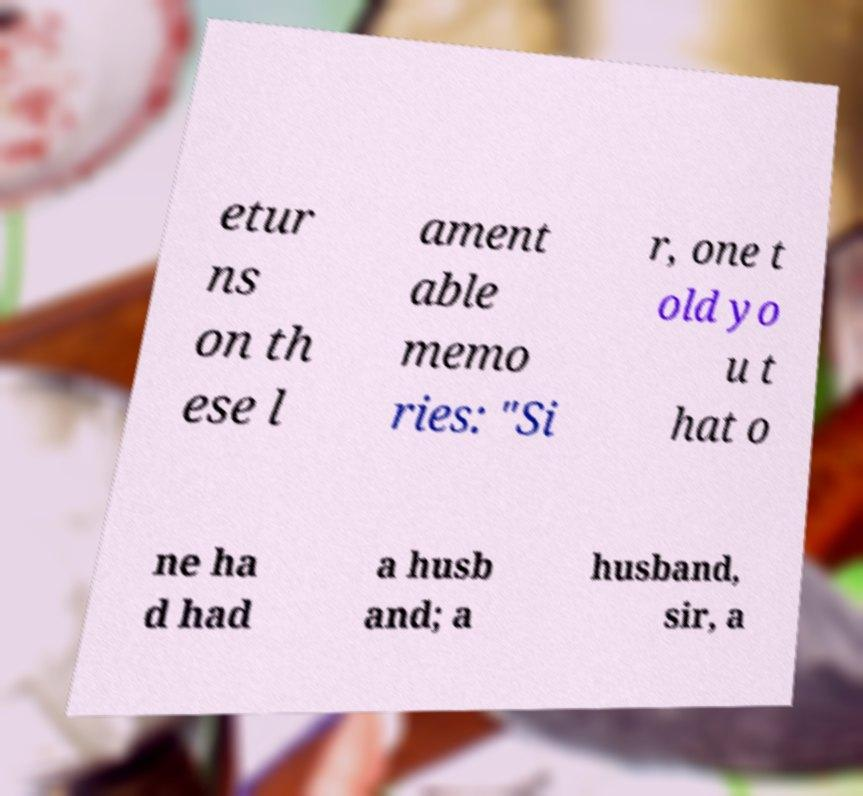I need the written content from this picture converted into text. Can you do that? etur ns on th ese l ament able memo ries: "Si r, one t old yo u t hat o ne ha d had a husb and; a husband, sir, a 